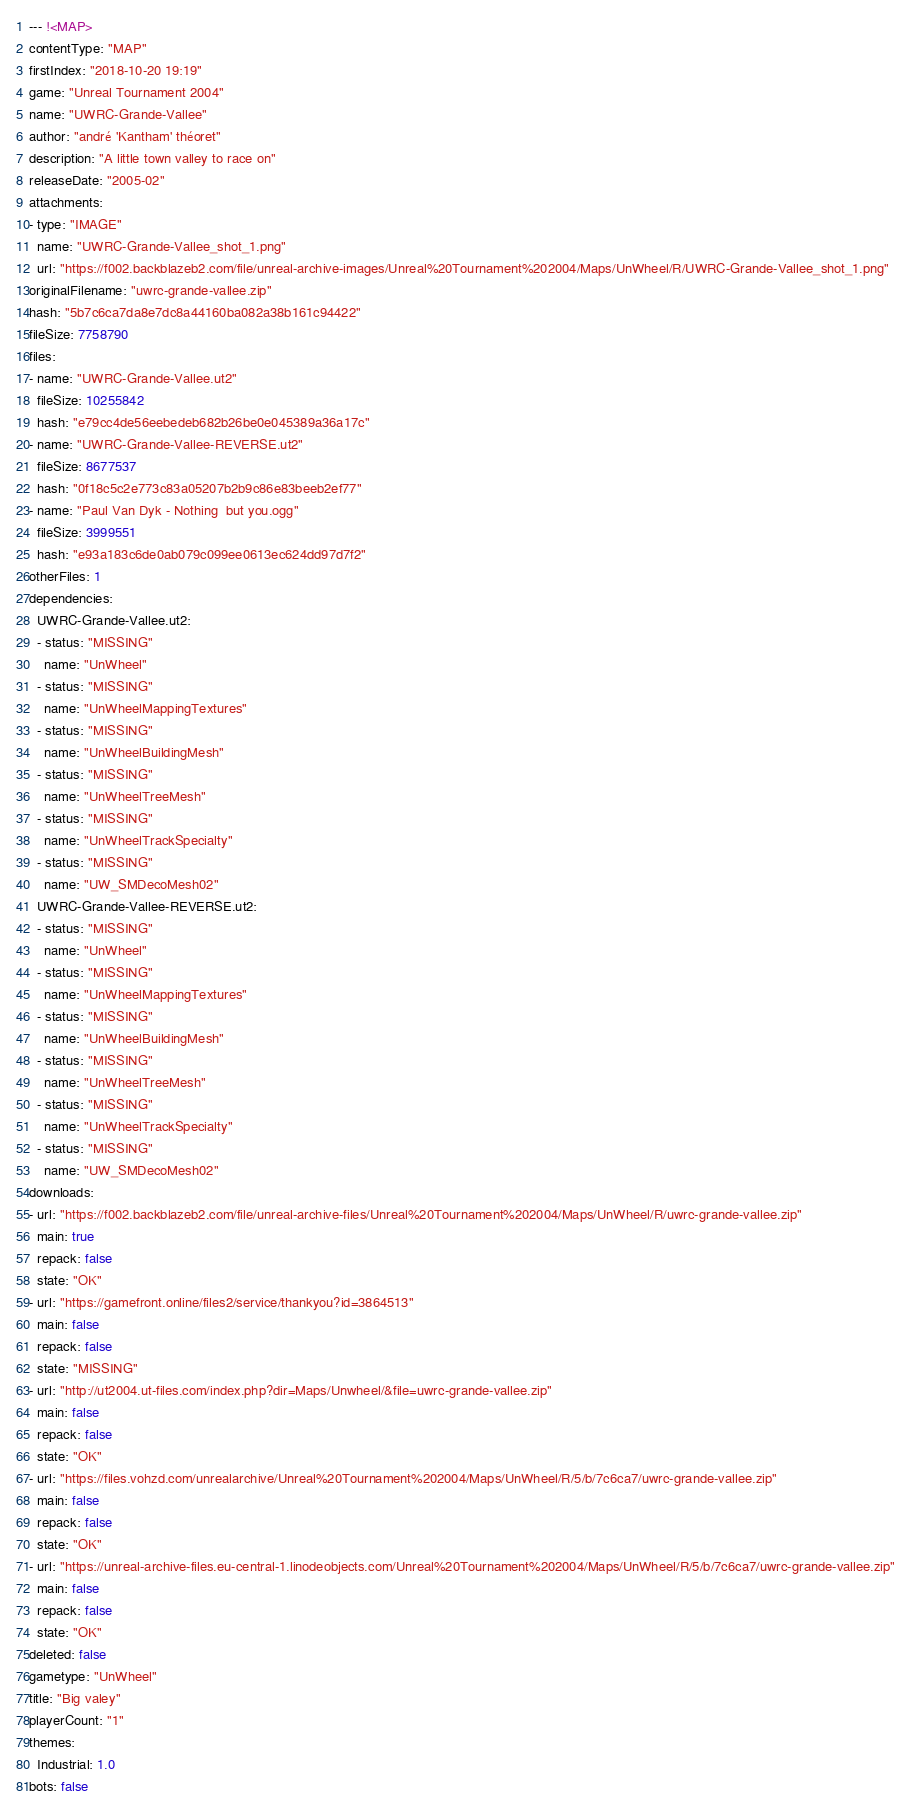Convert code to text. <code><loc_0><loc_0><loc_500><loc_500><_YAML_>--- !<MAP>
contentType: "MAP"
firstIndex: "2018-10-20 19:19"
game: "Unreal Tournament 2004"
name: "UWRC-Grande-Vallee"
author: "andré 'Kantham' théoret"
description: "A little town valley to race on"
releaseDate: "2005-02"
attachments:
- type: "IMAGE"
  name: "UWRC-Grande-Vallee_shot_1.png"
  url: "https://f002.backblazeb2.com/file/unreal-archive-images/Unreal%20Tournament%202004/Maps/UnWheel/R/UWRC-Grande-Vallee_shot_1.png"
originalFilename: "uwrc-grande-vallee.zip"
hash: "5b7c6ca7da8e7dc8a44160ba082a38b161c94422"
fileSize: 7758790
files:
- name: "UWRC-Grande-Vallee.ut2"
  fileSize: 10255842
  hash: "e79cc4de56eebedeb682b26be0e045389a36a17c"
- name: "UWRC-Grande-Vallee-REVERSE.ut2"
  fileSize: 8677537
  hash: "0f18c5c2e773c83a05207b2b9c86e83beeb2ef77"
- name: "Paul Van Dyk - Nothing  but you.ogg"
  fileSize: 3999551
  hash: "e93a183c6de0ab079c099ee0613ec624dd97d7f2"
otherFiles: 1
dependencies:
  UWRC-Grande-Vallee.ut2:
  - status: "MISSING"
    name: "UnWheel"
  - status: "MISSING"
    name: "UnWheelMappingTextures"
  - status: "MISSING"
    name: "UnWheelBuildingMesh"
  - status: "MISSING"
    name: "UnWheelTreeMesh"
  - status: "MISSING"
    name: "UnWheelTrackSpecialty"
  - status: "MISSING"
    name: "UW_SMDecoMesh02"
  UWRC-Grande-Vallee-REVERSE.ut2:
  - status: "MISSING"
    name: "UnWheel"
  - status: "MISSING"
    name: "UnWheelMappingTextures"
  - status: "MISSING"
    name: "UnWheelBuildingMesh"
  - status: "MISSING"
    name: "UnWheelTreeMesh"
  - status: "MISSING"
    name: "UnWheelTrackSpecialty"
  - status: "MISSING"
    name: "UW_SMDecoMesh02"
downloads:
- url: "https://f002.backblazeb2.com/file/unreal-archive-files/Unreal%20Tournament%202004/Maps/UnWheel/R/uwrc-grande-vallee.zip"
  main: true
  repack: false
  state: "OK"
- url: "https://gamefront.online/files2/service/thankyou?id=3864513"
  main: false
  repack: false
  state: "MISSING"
- url: "http://ut2004.ut-files.com/index.php?dir=Maps/Unwheel/&file=uwrc-grande-vallee.zip"
  main: false
  repack: false
  state: "OK"
- url: "https://files.vohzd.com/unrealarchive/Unreal%20Tournament%202004/Maps/UnWheel/R/5/b/7c6ca7/uwrc-grande-vallee.zip"
  main: false
  repack: false
  state: "OK"
- url: "https://unreal-archive-files.eu-central-1.linodeobjects.com/Unreal%20Tournament%202004/Maps/UnWheel/R/5/b/7c6ca7/uwrc-grande-vallee.zip"
  main: false
  repack: false
  state: "OK"
deleted: false
gametype: "UnWheel"
title: "Big valey"
playerCount: "1"
themes:
  Industrial: 1.0
bots: false
</code> 